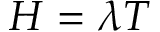<formula> <loc_0><loc_0><loc_500><loc_500>H = \lambda T</formula> 